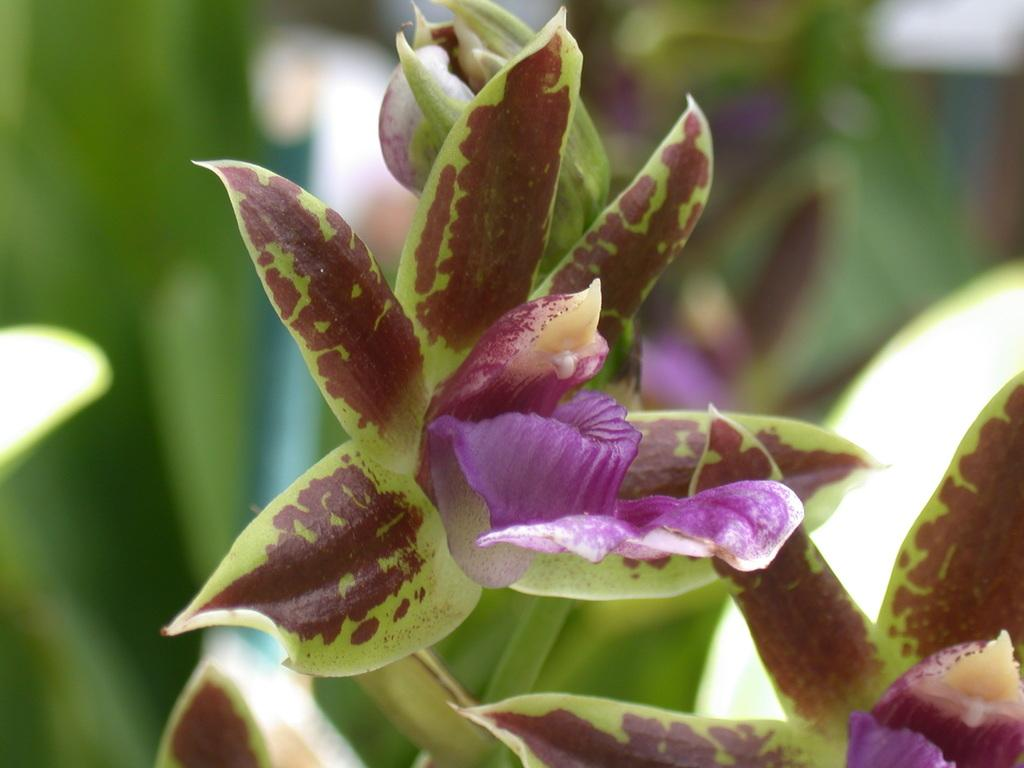What type of objects are present in the image? The image contains flowers. What colors can be seen on the flowers in the image? The flowers are in green and purple colors. How would you describe the background of the image? The background of the image is green and blurred. What type of caption is written on the flowers in the image? There is no caption written on the flowers in the image; it only contains visual elements. Can you see a nest in the image? There is no nest present in the image; it only contains flowers and a green, blurred background. 